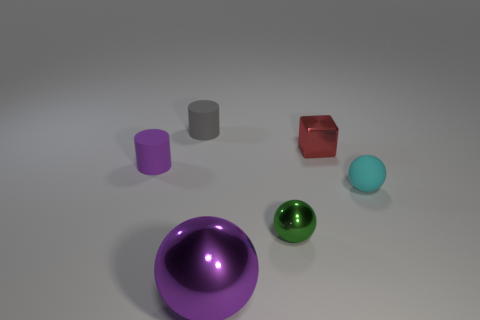Are these objects arranged in a specific pattern or order? The objects appear to be arranged in no discernible pattern, with varying shapes, sizes, and colors placed randomly across the surface. 